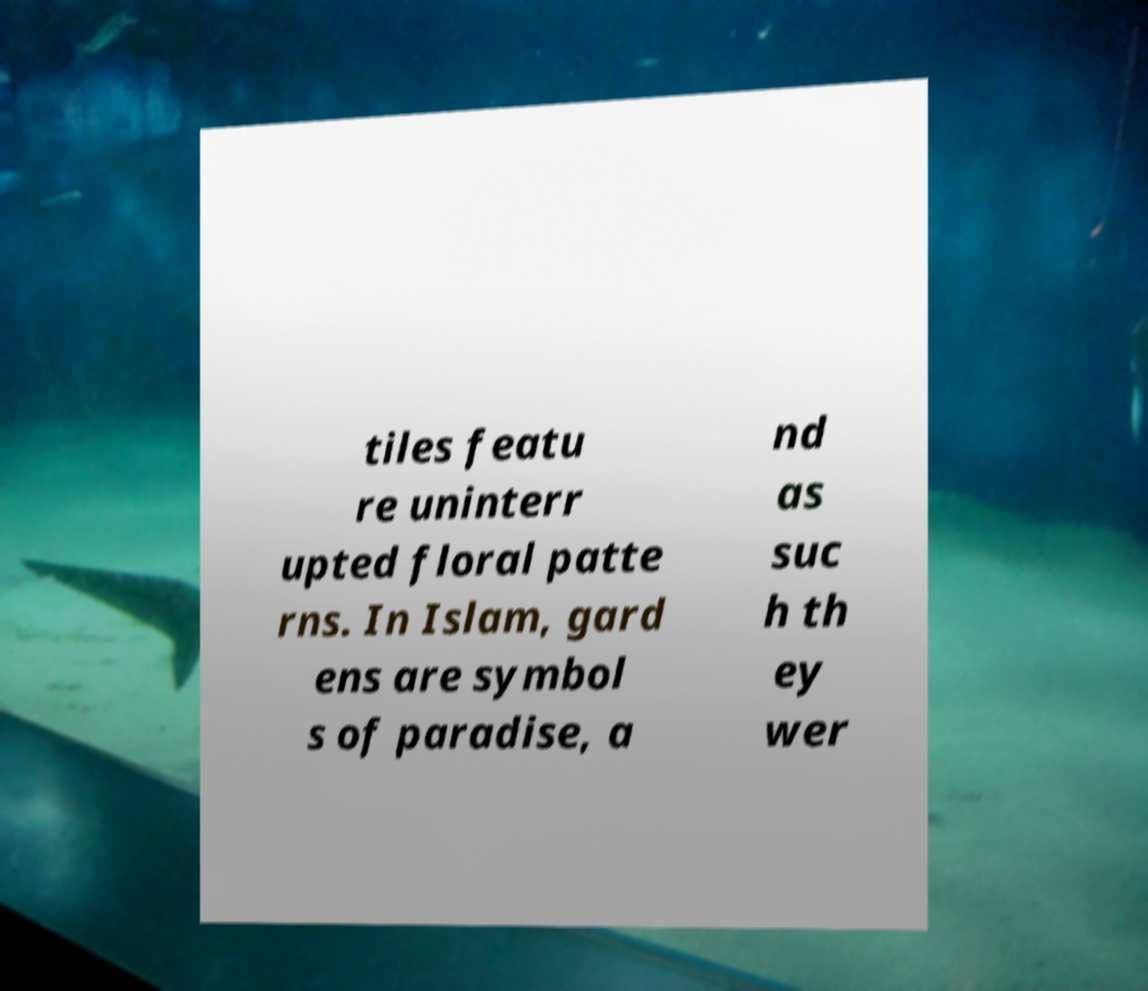Can you read and provide the text displayed in the image?This photo seems to have some interesting text. Can you extract and type it out for me? tiles featu re uninterr upted floral patte rns. In Islam, gard ens are symbol s of paradise, a nd as suc h th ey wer 